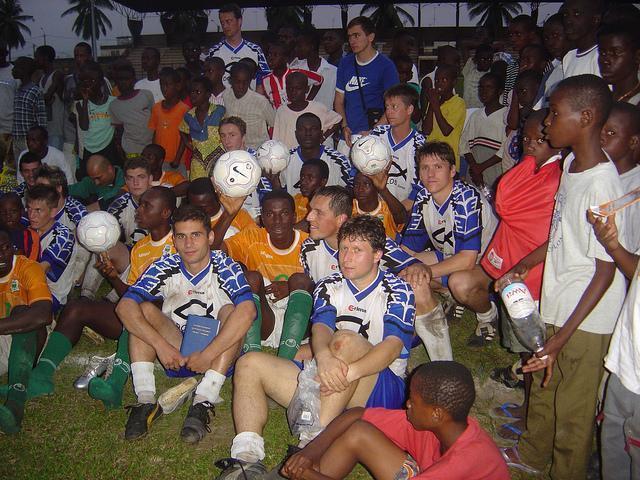How many soccer balls are in this picture?
Give a very brief answer. 4. How many people are there?
Give a very brief answer. 14. How many pizzas are there?
Give a very brief answer. 0. 